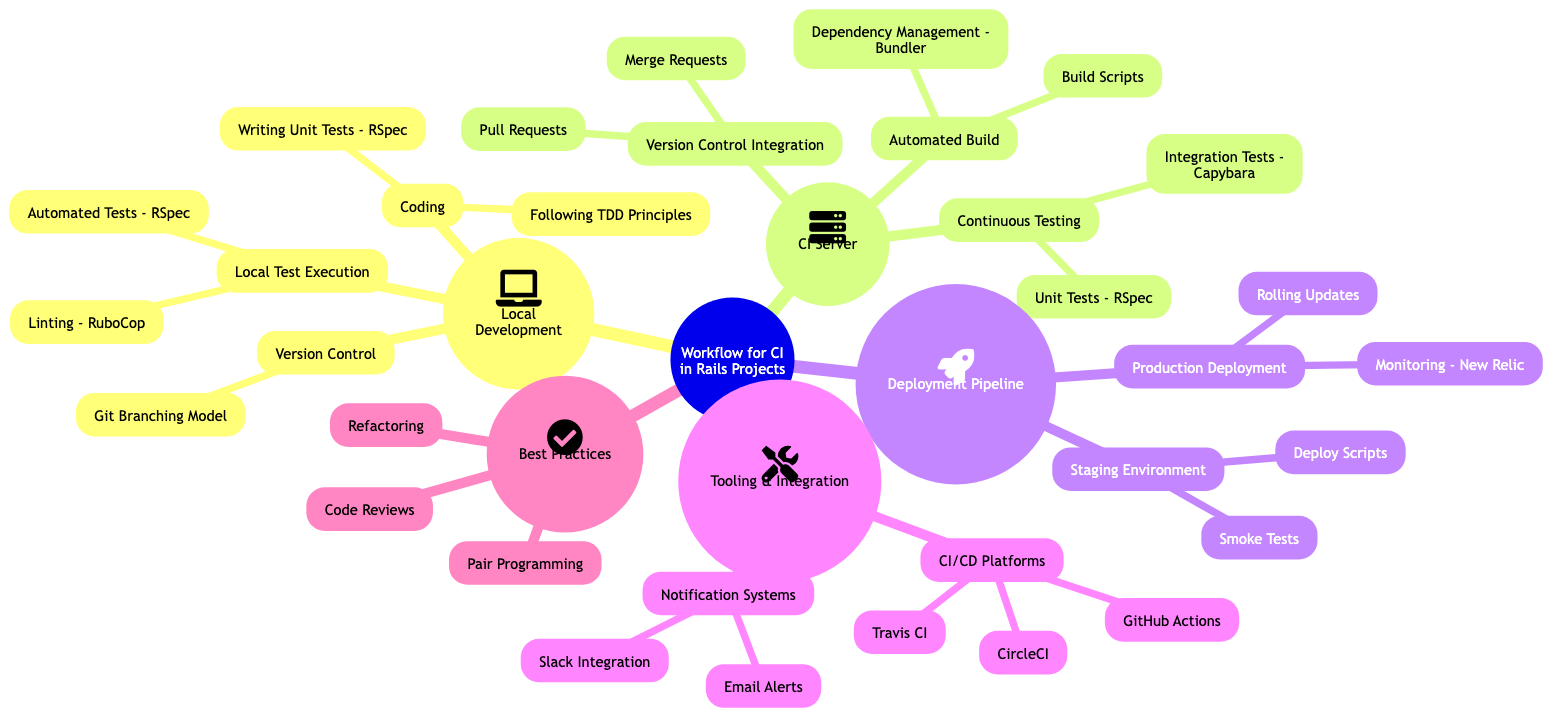What are the components of Local Development? The Local Development section has three main components: Version Control, Coding, and Local Test Execution. Each of these components represents a different aspect of the local development process.
Answer: Version Control, Coding, Local Test Execution How many CI/CD Platforms are listed? The Tooling & Integration section contains one node called CI/CD Platforms, which has three children: CircleCI, Travis CI, and GitHub Actions. Counting these children gives us a total of three CI/CD Platforms.
Answer: 3 What type of testing is included in Continuous Testing at the CI Server? The Continuous Testing component lists two types of testing: Unit Tests using RSpec and Integration Tests using Capybara. Both of these are important parts of the continuous testing process.
Answer: Unit Tests - RSpec, Integration Tests - Capybara Which tool is utilized for Linting in Local Test Execution? Within the Local Test Execution section, Linting is specifically addressed by mentioning RuboCop, which is a popular Ruby static code analyzer and code formatter used for ensuring code quality.
Answer: RuboCop What is the final step in the Deployment Pipeline? The Deployment Pipeline ends with the Production Deployment, which includes Rolling Updates and Monitoring using New Relic. Thus, the final step indicates a focus on effective production practices and system monitoring.
Answer: Monitoring - New Relic Describe the relationship between Coding and Testing in Local Development. Coding in Local Development involves following TDD principles and writing unit tests with RSpec. TDD (Test-Driven Development) dictates that tests are written before the actual code implementation, establishing a relationship where coding leads directly to writing tests, ensuring code quality and functionality.
Answer: TDD Principles How does Version Control Integration support the CI process? The Version Control Integration component features Pull Requests and Merge Requests as key elements. These elements enable the incorporation of code changes into shared repositories, facilitating collaboration and continuous integration by allowing team members to review and test code before merging it into the main branch.
Answer: Pull Requests, Merge Requests What are the two types of practices mentioned under Best Practices? The Best Practices section outlines three key practices: Code Reviews, Pair Programming, and Refactoring. These practices are crucial for maintaining code quality and fostering collaboration among team members in software development.
Answer: Code Reviews, Pair Programming, Refactoring 